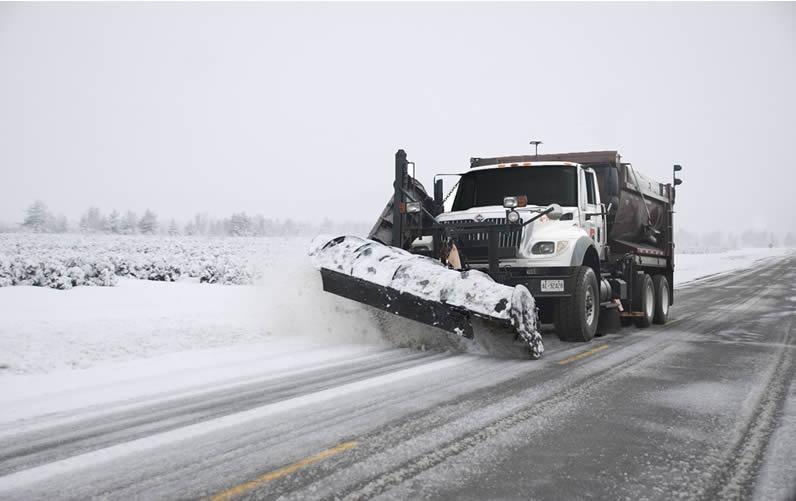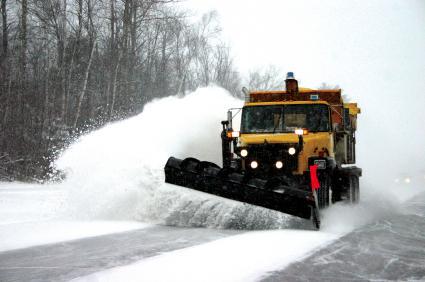The first image is the image on the left, the second image is the image on the right. For the images shown, is this caption "In one image, a white truck with snow blade is in a snowy area near trees, while a second image shows an orange truck with an angled orange blade." true? Answer yes or no. No. The first image is the image on the left, the second image is the image on the right. Assess this claim about the two images: "An image features a truck with an orange plow and orange cab on a non-snowy surface.". Correct or not? Answer yes or no. No. 